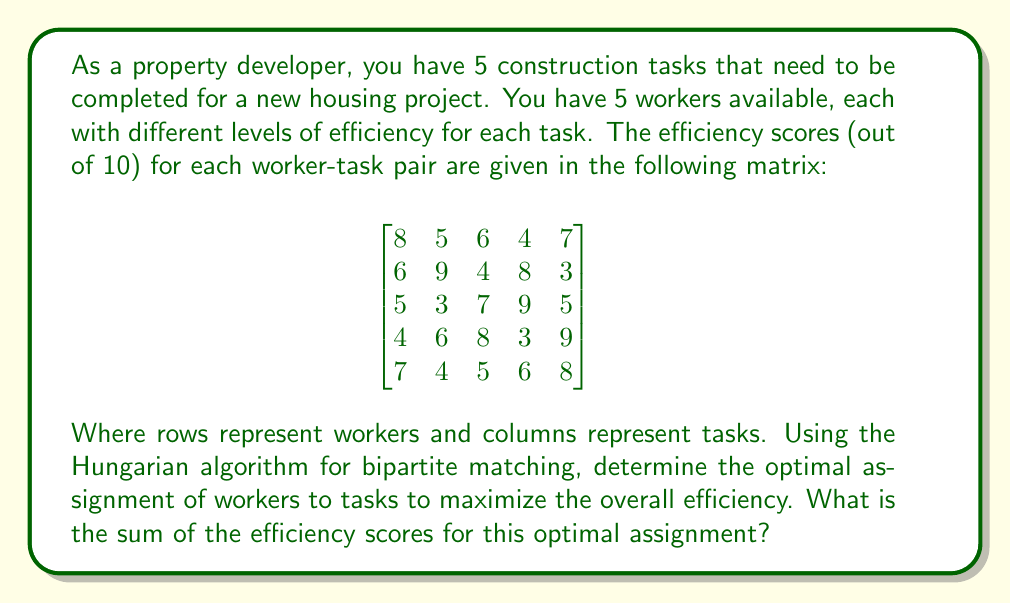Solve this math problem. To solve this problem using the Hungarian algorithm, we'll follow these steps:

1) First, we need to convert our maximization problem into a minimization problem. We can do this by subtracting each element from the maximum value in the matrix (9):

$$
\begin{bmatrix}
1 & 4 & 3 & 5 & 2 \\
3 & 0 & 5 & 1 & 6 \\
4 & 6 & 2 & 0 & 4 \\
5 & 3 & 1 & 6 & 0 \\
2 & 5 & 4 & 3 & 1
\end{bmatrix}
$$

2) For each row, subtract the smallest element:

$$
\begin{bmatrix}
0 & 3 & 2 & 4 & 1 \\
3 & 0 & 5 & 1 & 6 \\
4 & 6 & 2 & 0 & 4 \\
5 & 3 & 1 & 6 & 0 \\
1 & 4 & 3 & 2 & 0
\end{bmatrix}
$$

3) For each column, subtract the smallest element:

$$
\begin{bmatrix}
0 & 3 & 1 & 4 & 1 \\
3 & 0 & 4 & 1 & 6 \\
4 & 6 & 1 & 0 & 4 \\
5 & 3 & 0 & 6 & 0 \\
1 & 4 & 2 & 2 & 0
\end{bmatrix}
$$

4) Cover all zeros with the minimum number of lines:

[asy]
unitsize(30);
defaultpen(fontsize(10pt));

for(int i=0; i<5; ++i)
  for(int j=0; j<5; ++j)
    label(format("%d", (int)(new int[][]{
      {0,3,1,4,1},
      {3,0,4,1,6},
      {4,6,1,0,4},
      {5,3,0,6,0},
      {1,4,2,2,0}
    })[i][j]), (j,-i));

draw((-.5,0)--(4.5,0), red+1);
draw((1,0.5)--(1,-4.5), red+1);
draw((4,0.5)--(4,-4.5), red+1);
[/asy]

We need 3 lines, so we proceed to the next step.

5) Find the smallest uncovered element (1), subtract it from all uncovered elements and add it to elements covered twice:

$$
\begin{bmatrix}
0 & 2 & 0 & 3 & 1 \\
3 & 0 & 3 & 0 & 6 \\
4 & 5 & 0 & 0 & 4 \\
5 & 2 & 0 & 5 & 0 \\
1 & 3 & 1 & 1 & 0
\end{bmatrix}
$$

6) Repeat steps 4 and 5 until we can cover all zeros with 5 lines:

[asy]
unitsize(30);
defaultpen(fontsize(10pt));

for(int i=0; i<5; ++i)
  for(int j=0; j<5; ++j)
    label(format("%d", (int)(new int[][]{
      {0,2,0,3,1},
      {3,0,3,0,6},
      {4,5,0,0,4},
      {5,2,0,5,0},
      {1,3,1,1,0}
    })[i][j]), (j,-i));

draw((-.5,0)--(4.5,0), red+1);
draw((-.5,-1)--(4.5,-1), red+1);
draw((-.5,-3)--(4.5,-3), red+1);
draw((0,0.5)--(0,-4.5), red+1);
draw((2,0.5)--(2,-4.5), red+1);
[/asy]

7) The optimal assignment is where the zeros are located. In our original matrix, this corresponds to:

Worker 1 -> Task 1 (8)
Worker 2 -> Task 2 (9)
Worker 3 -> Task 4 (9)
Worker 4 -> Task 3 (8)
Worker 5 -> Task 5 (8)
Answer: The sum of the efficiency scores for the optimal assignment is $8 + 9 + 9 + 8 + 8 = 42$. 